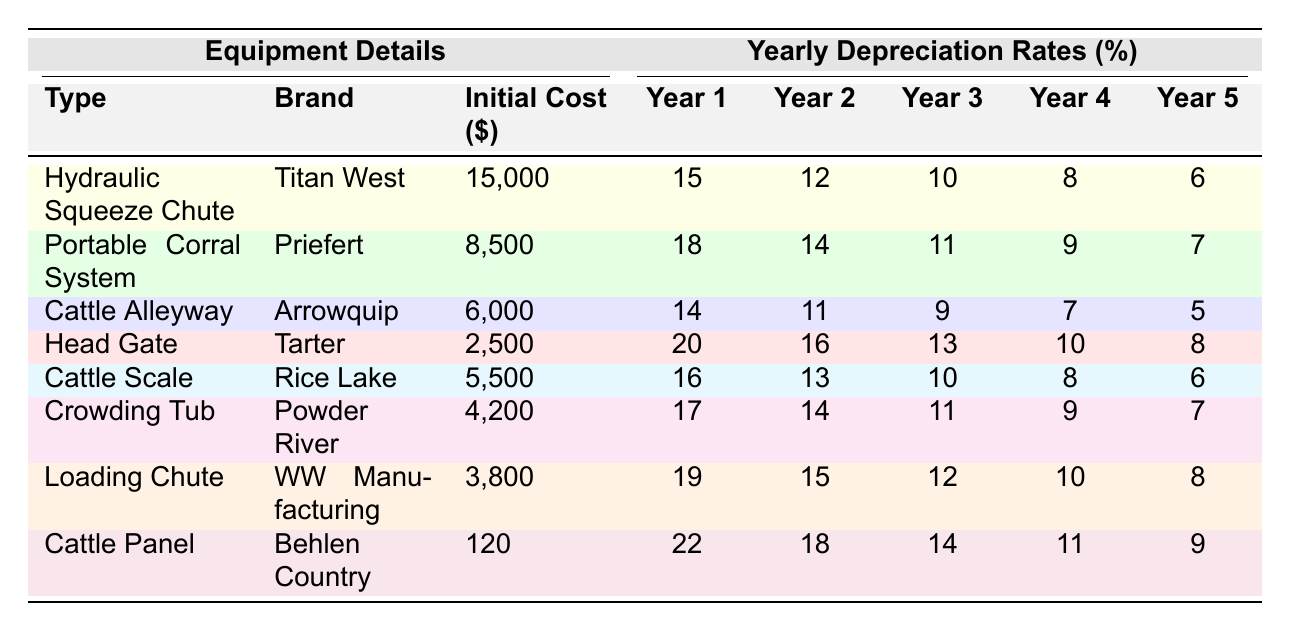What is the initial cost of the Hydraulic Squeeze Chute? The initial cost for the Hydraulic Squeeze Chute is listed directly in the table under the "Initial Cost" column. According to the data, it is $15,000.
Answer: $15,000 Which equipment has the highest year 1 depreciation rate? The year 1 depreciation rates for each piece of equipment are in the table. The Cattle Panel has a year 1 depreciation rate of 22%, which is higher than others.
Answer: Cattle Panel What is the total depreciation for the Loading Chute over the first 5 years? To find the total depreciation, we add all the yearly depreciation rates for the Loading Chute: 19 + 15 + 12 + 10 + 8 = 64.
Answer: 64% Is the year 3 depreciation rate for the Cattle Alleyway greater than 10%? Looking at the year 3 depreciation rate for the Cattle Alleyway, it is listed as 9%. Since 9% is less than 10%, the statement is false.
Answer: No Which equipment type has the lowest initial cost? The "Initial Cost" column allows comparison, and the Cattle Panel has the lowest cost listed at $120.
Answer: Cattle Panel What is the average year 2 depreciation rate of the equipment listed? We sum up the year 2 depreciation rates (12 + 14 + 11 + 16 + 13 + 14 + 15 + 18) =  119. There are 8 pieces of equipment, so the average depreciation rate is 119 / 8 = 14.875.
Answer: 14.875% If the Crowding Tub and the Cattle Scale were purchased, what would be their total initial cost? Adding the initial costs: Crowding Tub is $4,200, and Cattle Scale is $5,500. Therefore, the total initial cost is 4,200 + 5,500 = $9,700.
Answer: $9,700 How does the year 5 depreciation rate of the Head Gate compare to the year 5 rate of the Loading Chute? The year 5 depreciation rate for the Head Gate is 8%, and for the Loading Chute, it is also 8%. Since both values are equal, they compare as the same.
Answer: They are equal Which equipment has a decreasing depreciation rate each year? Analyzing the data shows that there are gradual decreases in depreciation rates each year for all equipment. We can confirm this is the case by reviewing each type.
Answer: All equipment What is the total depreciation of both the Portable Corral System and Cattle Panel after 3 years? The Portable Corral System has depreciation rates of 18, 14, and 11 for the first three years, adding up to 43. For the Cattle Panel, the depreciation rates for the same years are 22, 18, and 14, summing to 54. The total is 43 + 54 = 97.
Answer: 97% 